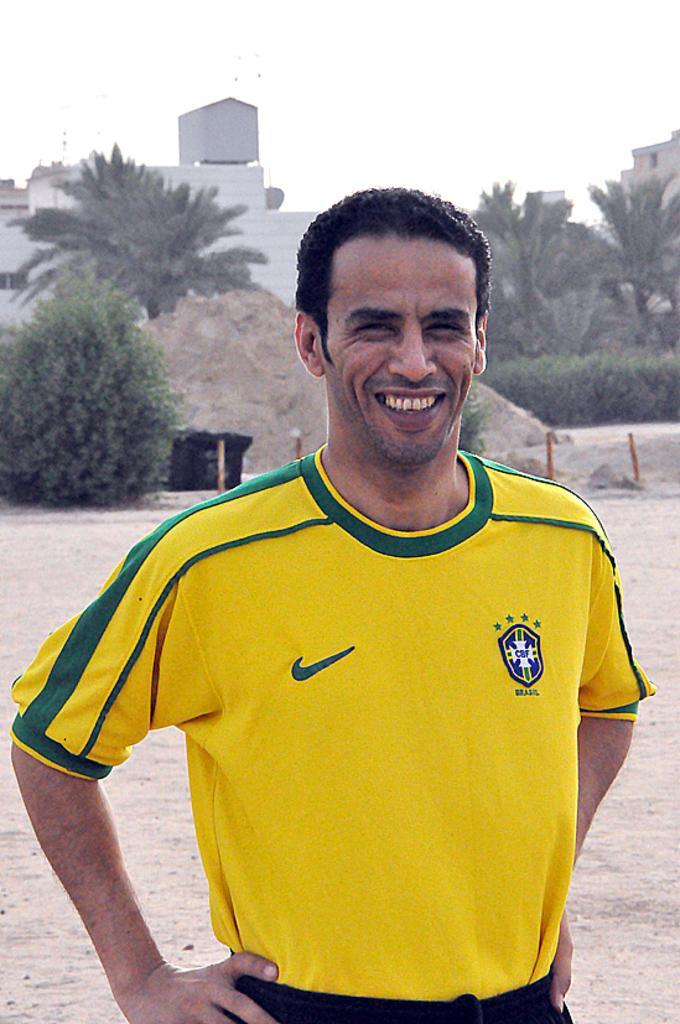In one or two sentences, can you explain what this image depicts? In this picture there is a person who is standing at the center of the image, there are some trees around the area of the image and there is a house behind him, it seems to be plane area where the man is standing. 